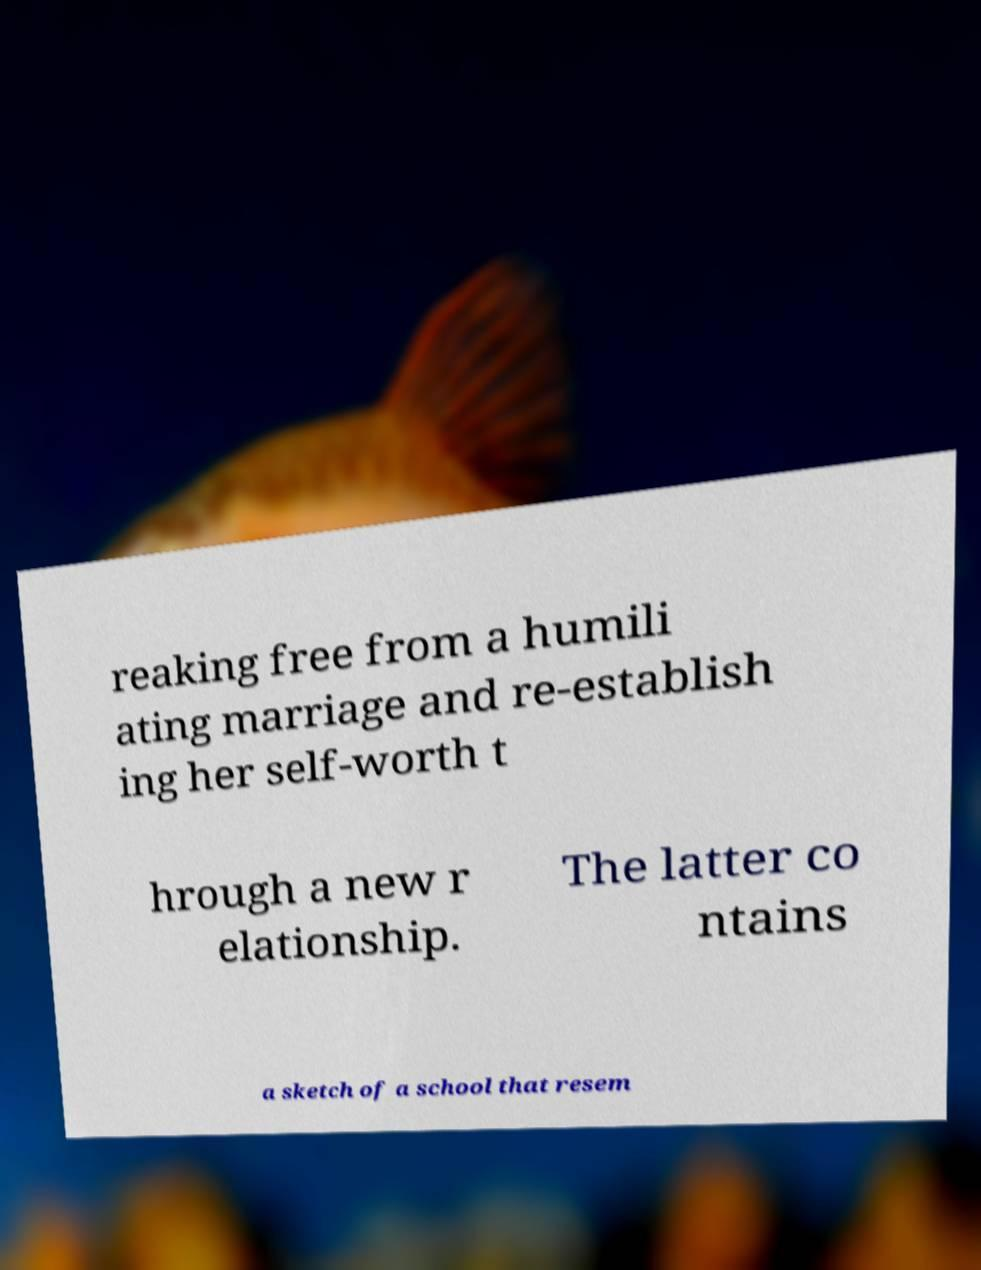Can you read and provide the text displayed in the image?This photo seems to have some interesting text. Can you extract and type it out for me? reaking free from a humili ating marriage and re-establish ing her self-worth t hrough a new r elationship. The latter co ntains a sketch of a school that resem 